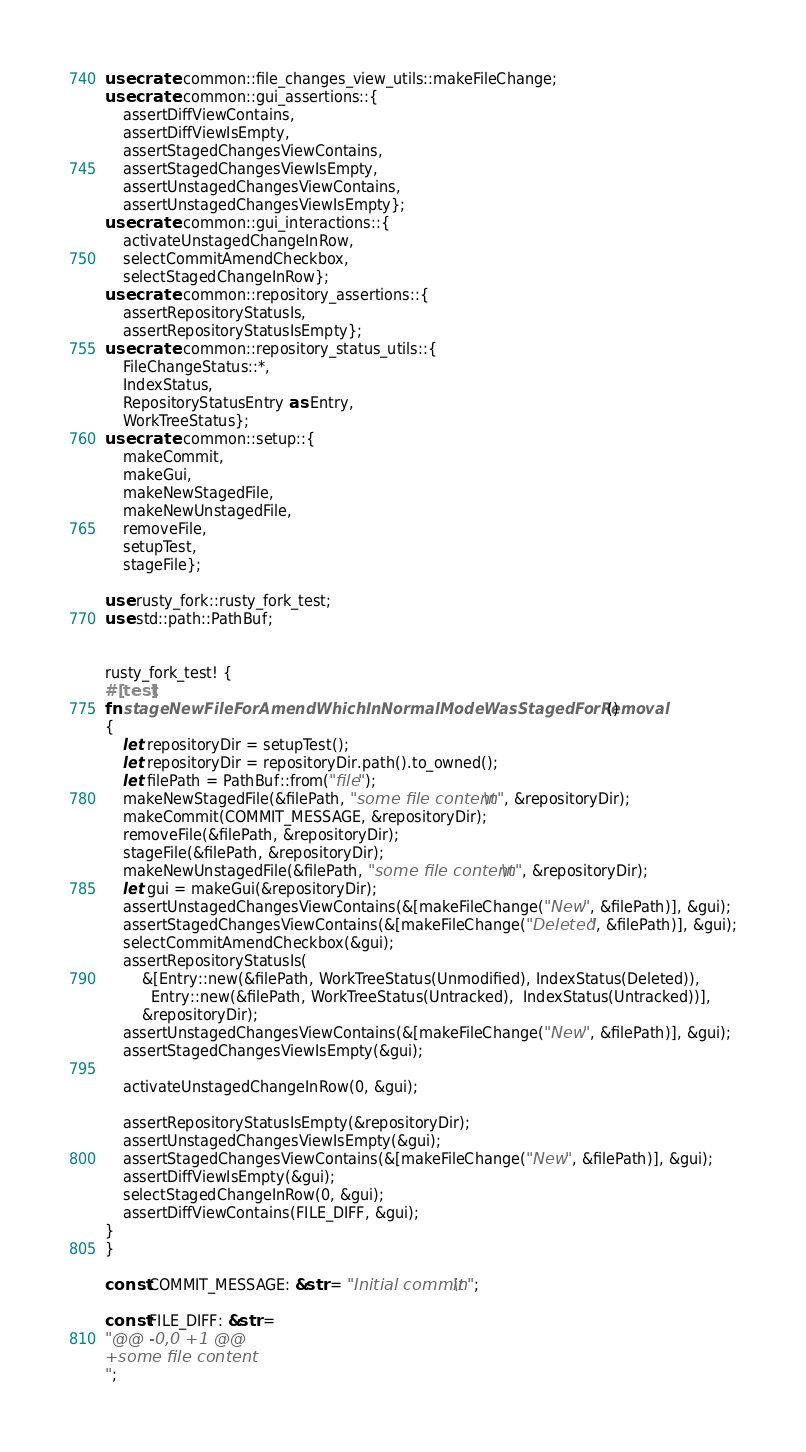Convert code to text. <code><loc_0><loc_0><loc_500><loc_500><_Rust_>use crate::common::file_changes_view_utils::makeFileChange;
use crate::common::gui_assertions::{
    assertDiffViewContains,
    assertDiffViewIsEmpty,
    assertStagedChangesViewContains,
    assertStagedChangesViewIsEmpty,
    assertUnstagedChangesViewContains,
    assertUnstagedChangesViewIsEmpty};
use crate::common::gui_interactions::{
    activateUnstagedChangeInRow,
    selectCommitAmendCheckbox,
    selectStagedChangeInRow};
use crate::common::repository_assertions::{
    assertRepositoryStatusIs,
    assertRepositoryStatusIsEmpty};
use crate::common::repository_status_utils::{
    FileChangeStatus::*,
    IndexStatus,
    RepositoryStatusEntry as Entry,
    WorkTreeStatus};
use crate::common::setup::{
    makeCommit,
    makeGui,
    makeNewStagedFile,
    makeNewUnstagedFile,
    removeFile,
    setupTest,
    stageFile};

use rusty_fork::rusty_fork_test;
use std::path::PathBuf;


rusty_fork_test! {
#[test]
fn stageNewFileForAmendWhichInNormalModeWasStagedForRemoval()
{
    let repositoryDir = setupTest();
    let repositoryDir = repositoryDir.path().to_owned();
    let filePath = PathBuf::from("file");
    makeNewStagedFile(&filePath, "some file content\n", &repositoryDir);
    makeCommit(COMMIT_MESSAGE, &repositoryDir);
    removeFile(&filePath, &repositoryDir);
    stageFile(&filePath, &repositoryDir);
    makeNewUnstagedFile(&filePath, "some file content\n", &repositoryDir);
    let gui = makeGui(&repositoryDir);
    assertUnstagedChangesViewContains(&[makeFileChange("New", &filePath)], &gui);
    assertStagedChangesViewContains(&[makeFileChange("Deleted", &filePath)], &gui);
    selectCommitAmendCheckbox(&gui);
    assertRepositoryStatusIs(
        &[Entry::new(&filePath, WorkTreeStatus(Unmodified), IndexStatus(Deleted)),
          Entry::new(&filePath, WorkTreeStatus(Untracked),  IndexStatus(Untracked))],
        &repositoryDir);
    assertUnstagedChangesViewContains(&[makeFileChange("New", &filePath)], &gui);
    assertStagedChangesViewIsEmpty(&gui);

    activateUnstagedChangeInRow(0, &gui);

    assertRepositoryStatusIsEmpty(&repositoryDir);
    assertUnstagedChangesViewIsEmpty(&gui);
    assertStagedChangesViewContains(&[makeFileChange("New", &filePath)], &gui);
    assertDiffViewIsEmpty(&gui);
    selectStagedChangeInRow(0, &gui);
    assertDiffViewContains(FILE_DIFF, &gui);
}
}

const COMMIT_MESSAGE: &str = "Initial commit\n";

const FILE_DIFF: &str =
"@@ -0,0 +1 @@
+some file content
";
</code> 